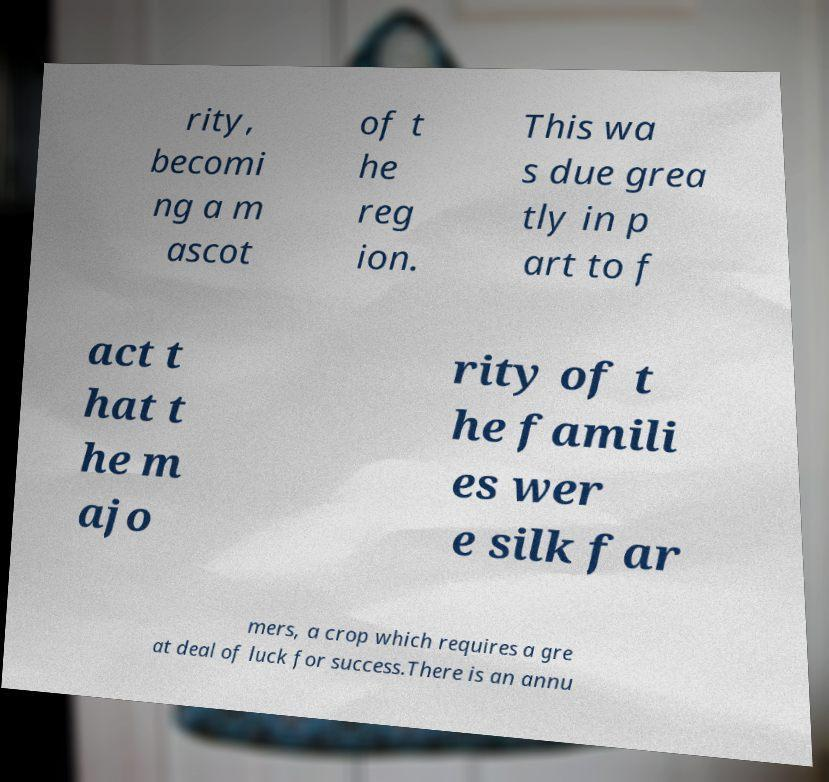Can you read and provide the text displayed in the image?This photo seems to have some interesting text. Can you extract and type it out for me? rity, becomi ng a m ascot of t he reg ion. This wa s due grea tly in p art to f act t hat t he m ajo rity of t he famili es wer e silk far mers, a crop which requires a gre at deal of luck for success.There is an annu 